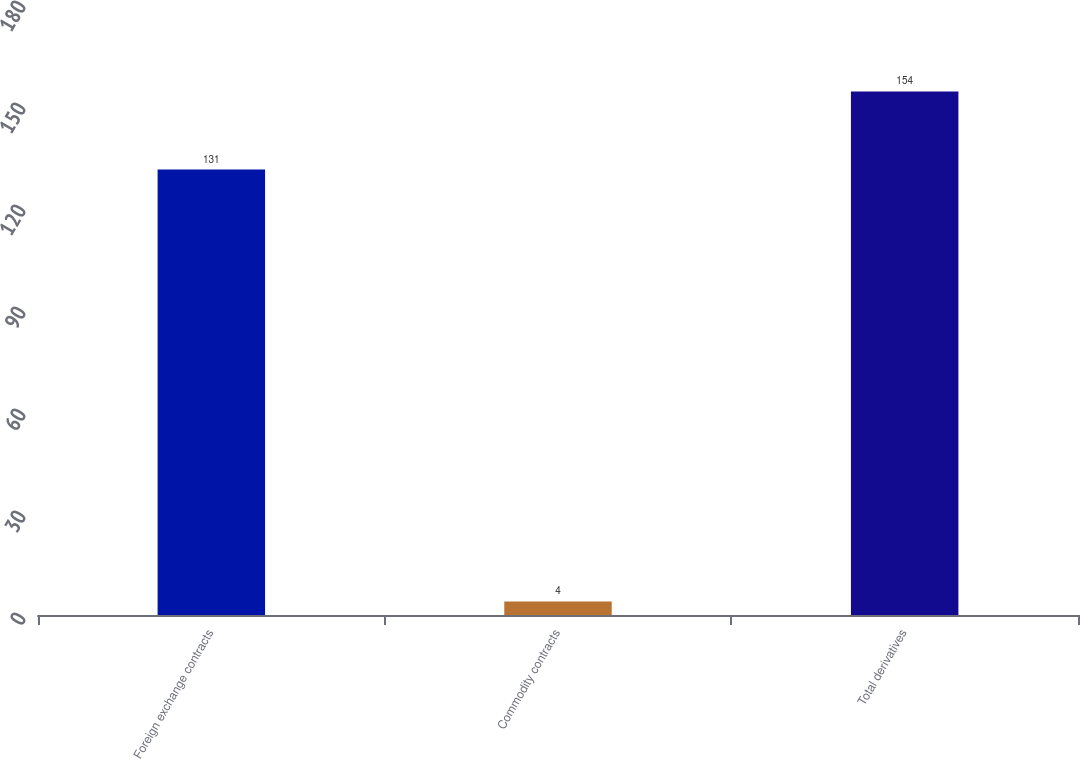<chart> <loc_0><loc_0><loc_500><loc_500><bar_chart><fcel>Foreign exchange contracts<fcel>Commodity contracts<fcel>Total derivatives<nl><fcel>131<fcel>4<fcel>154<nl></chart> 